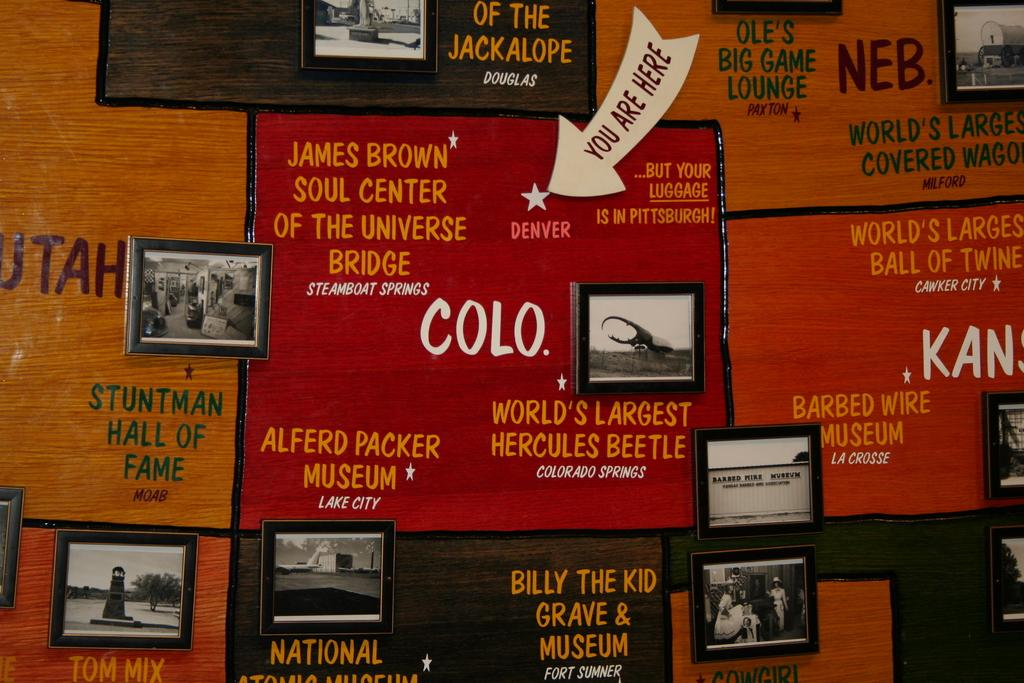<image>
Create a compact narrative representing the image presented. Ads for museums including one for COLO, the world's largest hercules  beetle. 